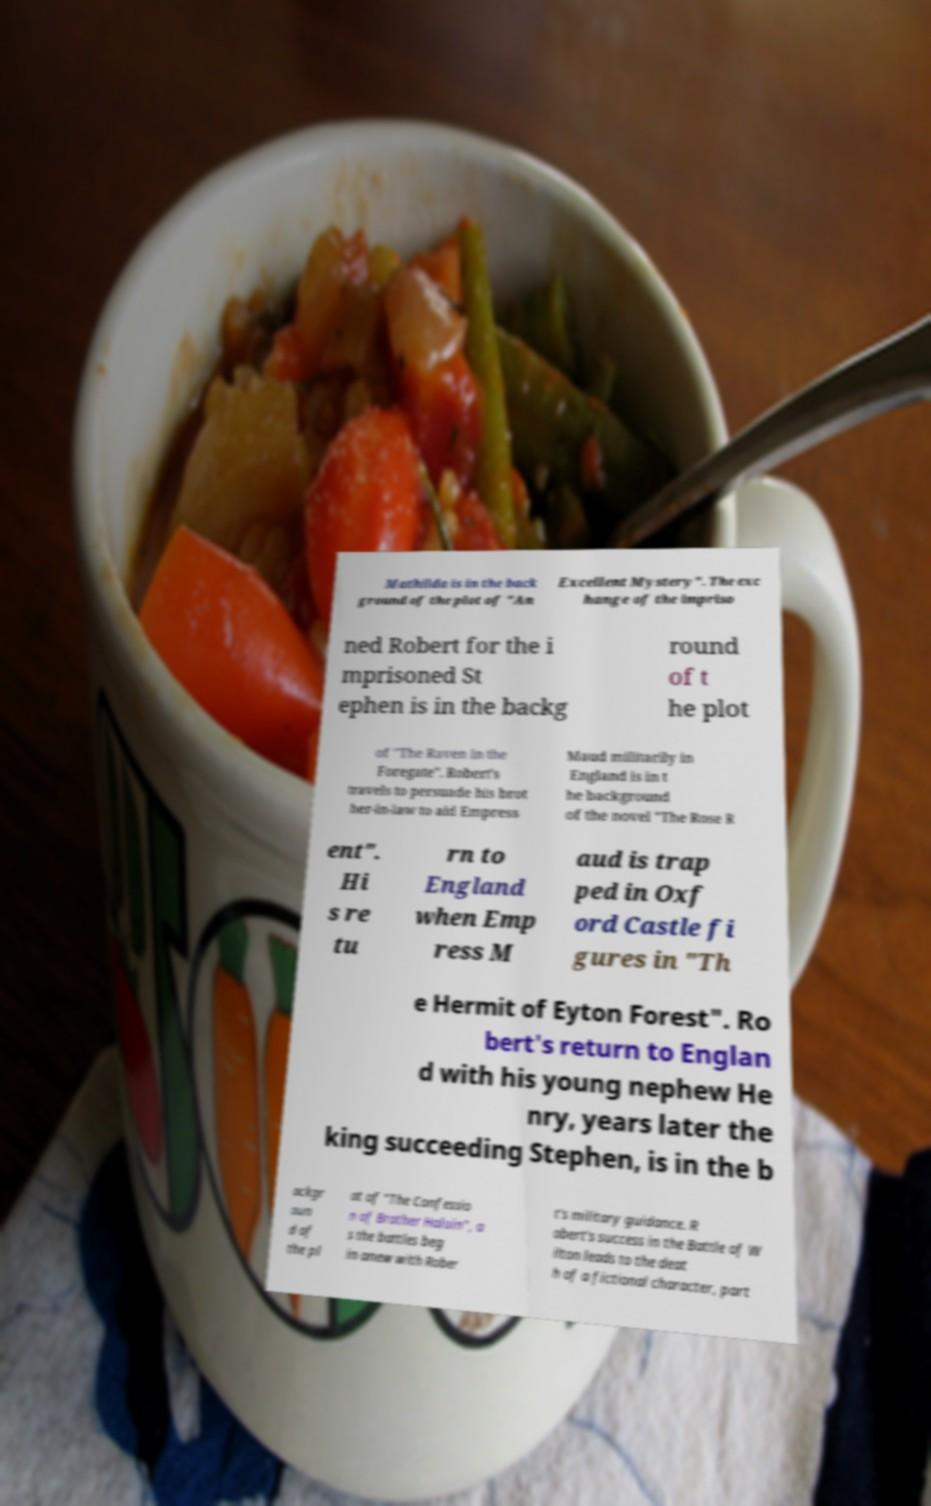Please read and relay the text visible in this image. What does it say? Mathilda is in the back ground of the plot of "An Excellent Mystery". The exc hange of the impriso ned Robert for the i mprisoned St ephen is in the backg round of t he plot of "The Raven in the Foregate". Robert's travels to persuade his brot her-in-law to aid Empress Maud militarily in England is in t he background of the novel "The Rose R ent". Hi s re tu rn to England when Emp ress M aud is trap ped in Oxf ord Castle fi gures in "Th e Hermit of Eyton Forest". Ro bert's return to Englan d with his young nephew He nry, years later the king succeeding Stephen, is in the b ackgr oun d of the pl ot of "The Confessio n of Brother Haluin", a s the battles beg in anew with Rober t's military guidance. R obert's success in the Battle of W ilton leads to the deat h of a fictional character, part 